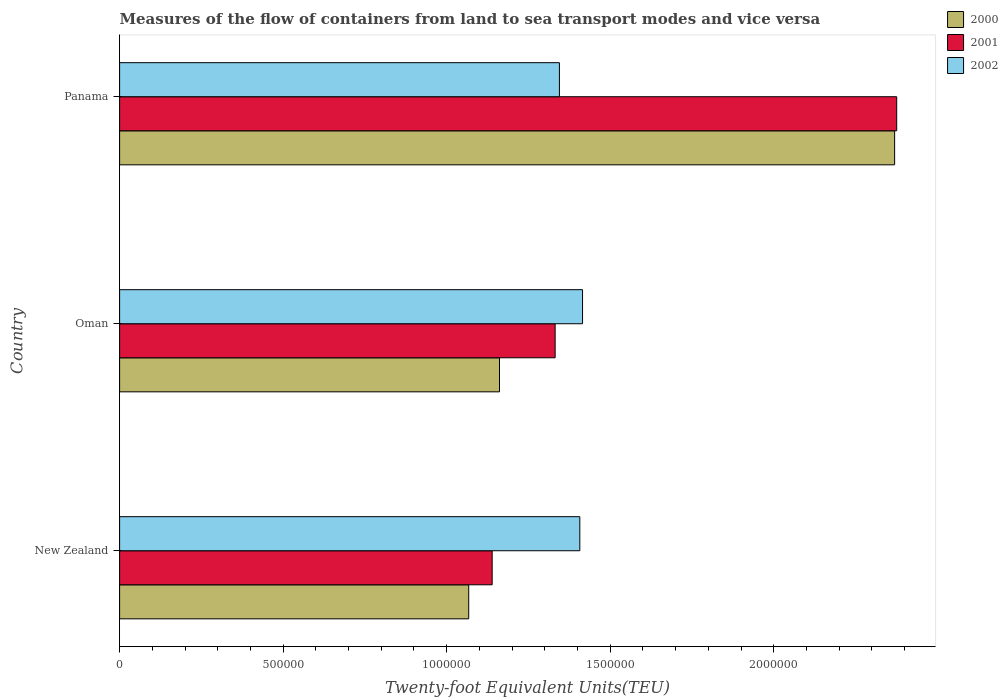How many groups of bars are there?
Offer a very short reply. 3. How many bars are there on the 2nd tick from the bottom?
Ensure brevity in your answer.  3. What is the label of the 3rd group of bars from the top?
Ensure brevity in your answer.  New Zealand. What is the container port traffic in 2002 in New Zealand?
Provide a short and direct response. 1.41e+06. Across all countries, what is the maximum container port traffic in 2000?
Give a very brief answer. 2.37e+06. Across all countries, what is the minimum container port traffic in 2002?
Offer a terse response. 1.34e+06. In which country was the container port traffic in 2000 maximum?
Make the answer very short. Panama. In which country was the container port traffic in 2000 minimum?
Keep it short and to the point. New Zealand. What is the total container port traffic in 2000 in the graph?
Your answer should be compact. 4.60e+06. What is the difference between the container port traffic in 2002 in New Zealand and that in Panama?
Keep it short and to the point. 6.23e+04. What is the difference between the container port traffic in 2002 in New Zealand and the container port traffic in 2001 in Panama?
Provide a short and direct response. -9.69e+05. What is the average container port traffic in 2001 per country?
Keep it short and to the point. 1.62e+06. What is the difference between the container port traffic in 2001 and container port traffic in 2002 in Oman?
Provide a short and direct response. -8.38e+04. In how many countries, is the container port traffic in 2002 greater than 400000 TEU?
Provide a short and direct response. 3. What is the ratio of the container port traffic in 2001 in Oman to that in Panama?
Your answer should be very brief. 0.56. What is the difference between the highest and the second highest container port traffic in 2002?
Your response must be concise. 8370. What is the difference between the highest and the lowest container port traffic in 2000?
Keep it short and to the point. 1.30e+06. Is the sum of the container port traffic in 2000 in New Zealand and Panama greater than the maximum container port traffic in 2002 across all countries?
Your response must be concise. Yes. What does the 1st bar from the top in Panama represents?
Your response must be concise. 2002. Is it the case that in every country, the sum of the container port traffic in 2000 and container port traffic in 2001 is greater than the container port traffic in 2002?
Provide a succinct answer. Yes. How many bars are there?
Provide a succinct answer. 9. How many countries are there in the graph?
Your answer should be very brief. 3. How are the legend labels stacked?
Give a very brief answer. Vertical. What is the title of the graph?
Offer a very short reply. Measures of the flow of containers from land to sea transport modes and vice versa. What is the label or title of the X-axis?
Make the answer very short. Twenty-foot Equivalent Units(TEU). What is the Twenty-foot Equivalent Units(TEU) in 2000 in New Zealand?
Give a very brief answer. 1.07e+06. What is the Twenty-foot Equivalent Units(TEU) in 2001 in New Zealand?
Offer a very short reply. 1.14e+06. What is the Twenty-foot Equivalent Units(TEU) in 2002 in New Zealand?
Your response must be concise. 1.41e+06. What is the Twenty-foot Equivalent Units(TEU) of 2000 in Oman?
Keep it short and to the point. 1.16e+06. What is the Twenty-foot Equivalent Units(TEU) in 2001 in Oman?
Provide a succinct answer. 1.33e+06. What is the Twenty-foot Equivalent Units(TEU) of 2002 in Oman?
Your answer should be very brief. 1.42e+06. What is the Twenty-foot Equivalent Units(TEU) of 2000 in Panama?
Keep it short and to the point. 2.37e+06. What is the Twenty-foot Equivalent Units(TEU) in 2001 in Panama?
Offer a very short reply. 2.38e+06. What is the Twenty-foot Equivalent Units(TEU) in 2002 in Panama?
Keep it short and to the point. 1.34e+06. Across all countries, what is the maximum Twenty-foot Equivalent Units(TEU) of 2000?
Your response must be concise. 2.37e+06. Across all countries, what is the maximum Twenty-foot Equivalent Units(TEU) of 2001?
Your answer should be compact. 2.38e+06. Across all countries, what is the maximum Twenty-foot Equivalent Units(TEU) of 2002?
Offer a terse response. 1.42e+06. Across all countries, what is the minimum Twenty-foot Equivalent Units(TEU) in 2000?
Your answer should be very brief. 1.07e+06. Across all countries, what is the minimum Twenty-foot Equivalent Units(TEU) in 2001?
Provide a succinct answer. 1.14e+06. Across all countries, what is the minimum Twenty-foot Equivalent Units(TEU) in 2002?
Give a very brief answer. 1.34e+06. What is the total Twenty-foot Equivalent Units(TEU) in 2000 in the graph?
Provide a succinct answer. 4.60e+06. What is the total Twenty-foot Equivalent Units(TEU) in 2001 in the graph?
Offer a very short reply. 4.85e+06. What is the total Twenty-foot Equivalent Units(TEU) in 2002 in the graph?
Ensure brevity in your answer.  4.17e+06. What is the difference between the Twenty-foot Equivalent Units(TEU) of 2000 in New Zealand and that in Oman?
Offer a terse response. -9.41e+04. What is the difference between the Twenty-foot Equivalent Units(TEU) of 2001 in New Zealand and that in Oman?
Provide a succinct answer. -1.93e+05. What is the difference between the Twenty-foot Equivalent Units(TEU) in 2002 in New Zealand and that in Oman?
Make the answer very short. -8370. What is the difference between the Twenty-foot Equivalent Units(TEU) in 2000 in New Zealand and that in Panama?
Ensure brevity in your answer.  -1.30e+06. What is the difference between the Twenty-foot Equivalent Units(TEU) in 2001 in New Zealand and that in Panama?
Make the answer very short. -1.24e+06. What is the difference between the Twenty-foot Equivalent Units(TEU) of 2002 in New Zealand and that in Panama?
Your answer should be compact. 6.23e+04. What is the difference between the Twenty-foot Equivalent Units(TEU) of 2000 in Oman and that in Panama?
Provide a short and direct response. -1.21e+06. What is the difference between the Twenty-foot Equivalent Units(TEU) of 2001 in Oman and that in Panama?
Give a very brief answer. -1.04e+06. What is the difference between the Twenty-foot Equivalent Units(TEU) of 2002 in Oman and that in Panama?
Provide a succinct answer. 7.07e+04. What is the difference between the Twenty-foot Equivalent Units(TEU) in 2000 in New Zealand and the Twenty-foot Equivalent Units(TEU) in 2001 in Oman?
Give a very brief answer. -2.64e+05. What is the difference between the Twenty-foot Equivalent Units(TEU) of 2000 in New Zealand and the Twenty-foot Equivalent Units(TEU) of 2002 in Oman?
Your answer should be very brief. -3.48e+05. What is the difference between the Twenty-foot Equivalent Units(TEU) in 2001 in New Zealand and the Twenty-foot Equivalent Units(TEU) in 2002 in Oman?
Your response must be concise. -2.76e+05. What is the difference between the Twenty-foot Equivalent Units(TEU) in 2000 in New Zealand and the Twenty-foot Equivalent Units(TEU) in 2001 in Panama?
Your response must be concise. -1.31e+06. What is the difference between the Twenty-foot Equivalent Units(TEU) in 2000 in New Zealand and the Twenty-foot Equivalent Units(TEU) in 2002 in Panama?
Provide a succinct answer. -2.77e+05. What is the difference between the Twenty-foot Equivalent Units(TEU) of 2001 in New Zealand and the Twenty-foot Equivalent Units(TEU) of 2002 in Panama?
Provide a short and direct response. -2.06e+05. What is the difference between the Twenty-foot Equivalent Units(TEU) in 2000 in Oman and the Twenty-foot Equivalent Units(TEU) in 2001 in Panama?
Ensure brevity in your answer.  -1.21e+06. What is the difference between the Twenty-foot Equivalent Units(TEU) in 2000 in Oman and the Twenty-foot Equivalent Units(TEU) in 2002 in Panama?
Give a very brief answer. -1.83e+05. What is the difference between the Twenty-foot Equivalent Units(TEU) in 2001 in Oman and the Twenty-foot Equivalent Units(TEU) in 2002 in Panama?
Your response must be concise. -1.31e+04. What is the average Twenty-foot Equivalent Units(TEU) in 2000 per country?
Your answer should be very brief. 1.53e+06. What is the average Twenty-foot Equivalent Units(TEU) of 2001 per country?
Keep it short and to the point. 1.62e+06. What is the average Twenty-foot Equivalent Units(TEU) of 2002 per country?
Offer a very short reply. 1.39e+06. What is the difference between the Twenty-foot Equivalent Units(TEU) of 2000 and Twenty-foot Equivalent Units(TEU) of 2001 in New Zealand?
Provide a succinct answer. -7.17e+04. What is the difference between the Twenty-foot Equivalent Units(TEU) in 2000 and Twenty-foot Equivalent Units(TEU) in 2002 in New Zealand?
Offer a very short reply. -3.40e+05. What is the difference between the Twenty-foot Equivalent Units(TEU) in 2001 and Twenty-foot Equivalent Units(TEU) in 2002 in New Zealand?
Make the answer very short. -2.68e+05. What is the difference between the Twenty-foot Equivalent Units(TEU) of 2000 and Twenty-foot Equivalent Units(TEU) of 2001 in Oman?
Your answer should be very brief. -1.70e+05. What is the difference between the Twenty-foot Equivalent Units(TEU) in 2000 and Twenty-foot Equivalent Units(TEU) in 2002 in Oman?
Offer a very short reply. -2.54e+05. What is the difference between the Twenty-foot Equivalent Units(TEU) in 2001 and Twenty-foot Equivalent Units(TEU) in 2002 in Oman?
Ensure brevity in your answer.  -8.38e+04. What is the difference between the Twenty-foot Equivalent Units(TEU) in 2000 and Twenty-foot Equivalent Units(TEU) in 2001 in Panama?
Your answer should be very brief. -6364. What is the difference between the Twenty-foot Equivalent Units(TEU) of 2000 and Twenty-foot Equivalent Units(TEU) of 2002 in Panama?
Keep it short and to the point. 1.02e+06. What is the difference between the Twenty-foot Equivalent Units(TEU) in 2001 and Twenty-foot Equivalent Units(TEU) in 2002 in Panama?
Offer a terse response. 1.03e+06. What is the ratio of the Twenty-foot Equivalent Units(TEU) in 2000 in New Zealand to that in Oman?
Ensure brevity in your answer.  0.92. What is the ratio of the Twenty-foot Equivalent Units(TEU) of 2001 in New Zealand to that in Oman?
Provide a succinct answer. 0.86. What is the ratio of the Twenty-foot Equivalent Units(TEU) of 2002 in New Zealand to that in Oman?
Your response must be concise. 0.99. What is the ratio of the Twenty-foot Equivalent Units(TEU) of 2000 in New Zealand to that in Panama?
Your answer should be very brief. 0.45. What is the ratio of the Twenty-foot Equivalent Units(TEU) of 2001 in New Zealand to that in Panama?
Your response must be concise. 0.48. What is the ratio of the Twenty-foot Equivalent Units(TEU) in 2002 in New Zealand to that in Panama?
Your answer should be very brief. 1.05. What is the ratio of the Twenty-foot Equivalent Units(TEU) of 2000 in Oman to that in Panama?
Offer a very short reply. 0.49. What is the ratio of the Twenty-foot Equivalent Units(TEU) of 2001 in Oman to that in Panama?
Provide a short and direct response. 0.56. What is the ratio of the Twenty-foot Equivalent Units(TEU) in 2002 in Oman to that in Panama?
Keep it short and to the point. 1.05. What is the difference between the highest and the second highest Twenty-foot Equivalent Units(TEU) of 2000?
Provide a short and direct response. 1.21e+06. What is the difference between the highest and the second highest Twenty-foot Equivalent Units(TEU) of 2001?
Ensure brevity in your answer.  1.04e+06. What is the difference between the highest and the second highest Twenty-foot Equivalent Units(TEU) of 2002?
Offer a terse response. 8370. What is the difference between the highest and the lowest Twenty-foot Equivalent Units(TEU) in 2000?
Your answer should be very brief. 1.30e+06. What is the difference between the highest and the lowest Twenty-foot Equivalent Units(TEU) in 2001?
Keep it short and to the point. 1.24e+06. What is the difference between the highest and the lowest Twenty-foot Equivalent Units(TEU) in 2002?
Your answer should be very brief. 7.07e+04. 